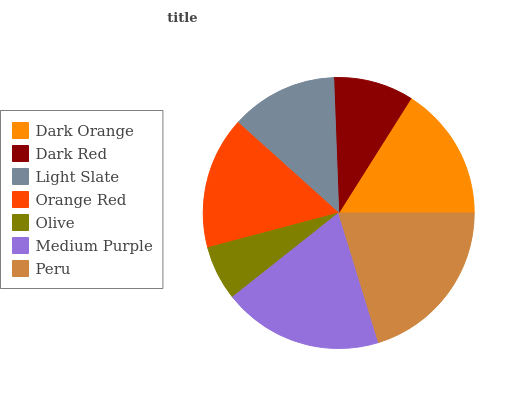Is Olive the minimum?
Answer yes or no. Yes. Is Peru the maximum?
Answer yes or no. Yes. Is Dark Red the minimum?
Answer yes or no. No. Is Dark Red the maximum?
Answer yes or no. No. Is Dark Orange greater than Dark Red?
Answer yes or no. Yes. Is Dark Red less than Dark Orange?
Answer yes or no. Yes. Is Dark Red greater than Dark Orange?
Answer yes or no. No. Is Dark Orange less than Dark Red?
Answer yes or no. No. Is Orange Red the high median?
Answer yes or no. Yes. Is Orange Red the low median?
Answer yes or no. Yes. Is Dark Orange the high median?
Answer yes or no. No. Is Olive the low median?
Answer yes or no. No. 